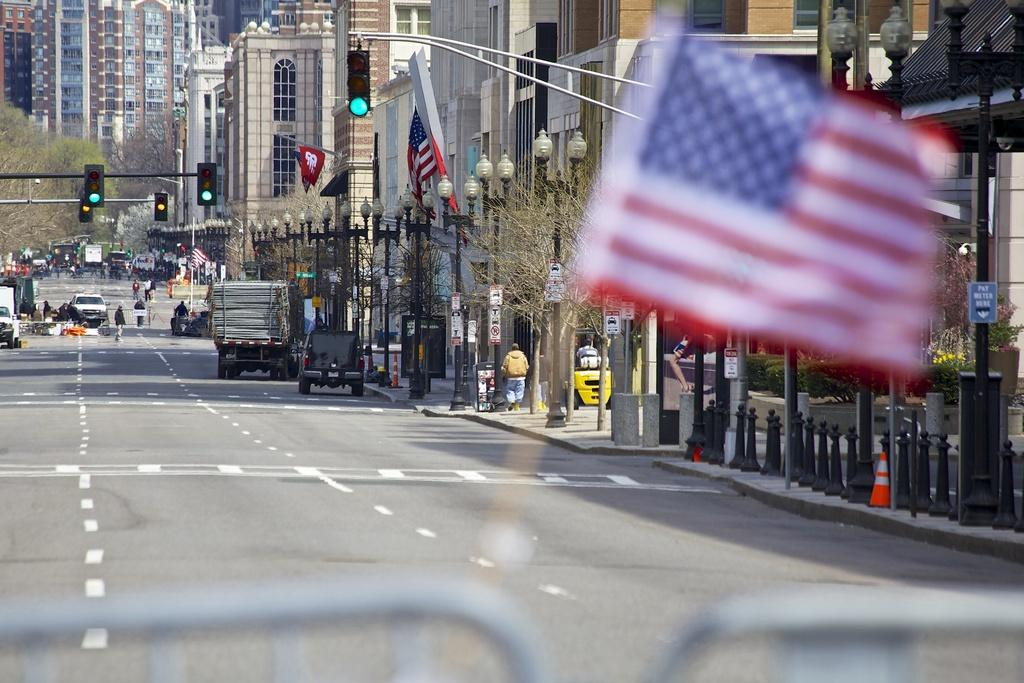What type of view is depicted in the image? The image is a street view. What can be seen on the right side of the image? There are buildings on the right side of the image. What additional features are visible in the image? There are flags and light poles in the image. Who or what else is present in the image? There are people on the road and vehicles in the image. What type of pies are being sold by the people on the road in the image? There is no indication in the image that pies are being sold or that the people on the road are selling anything. What is the average income of the people in the image? There is no information about the income of the people in the image, as it is not relevant to the visual content. 